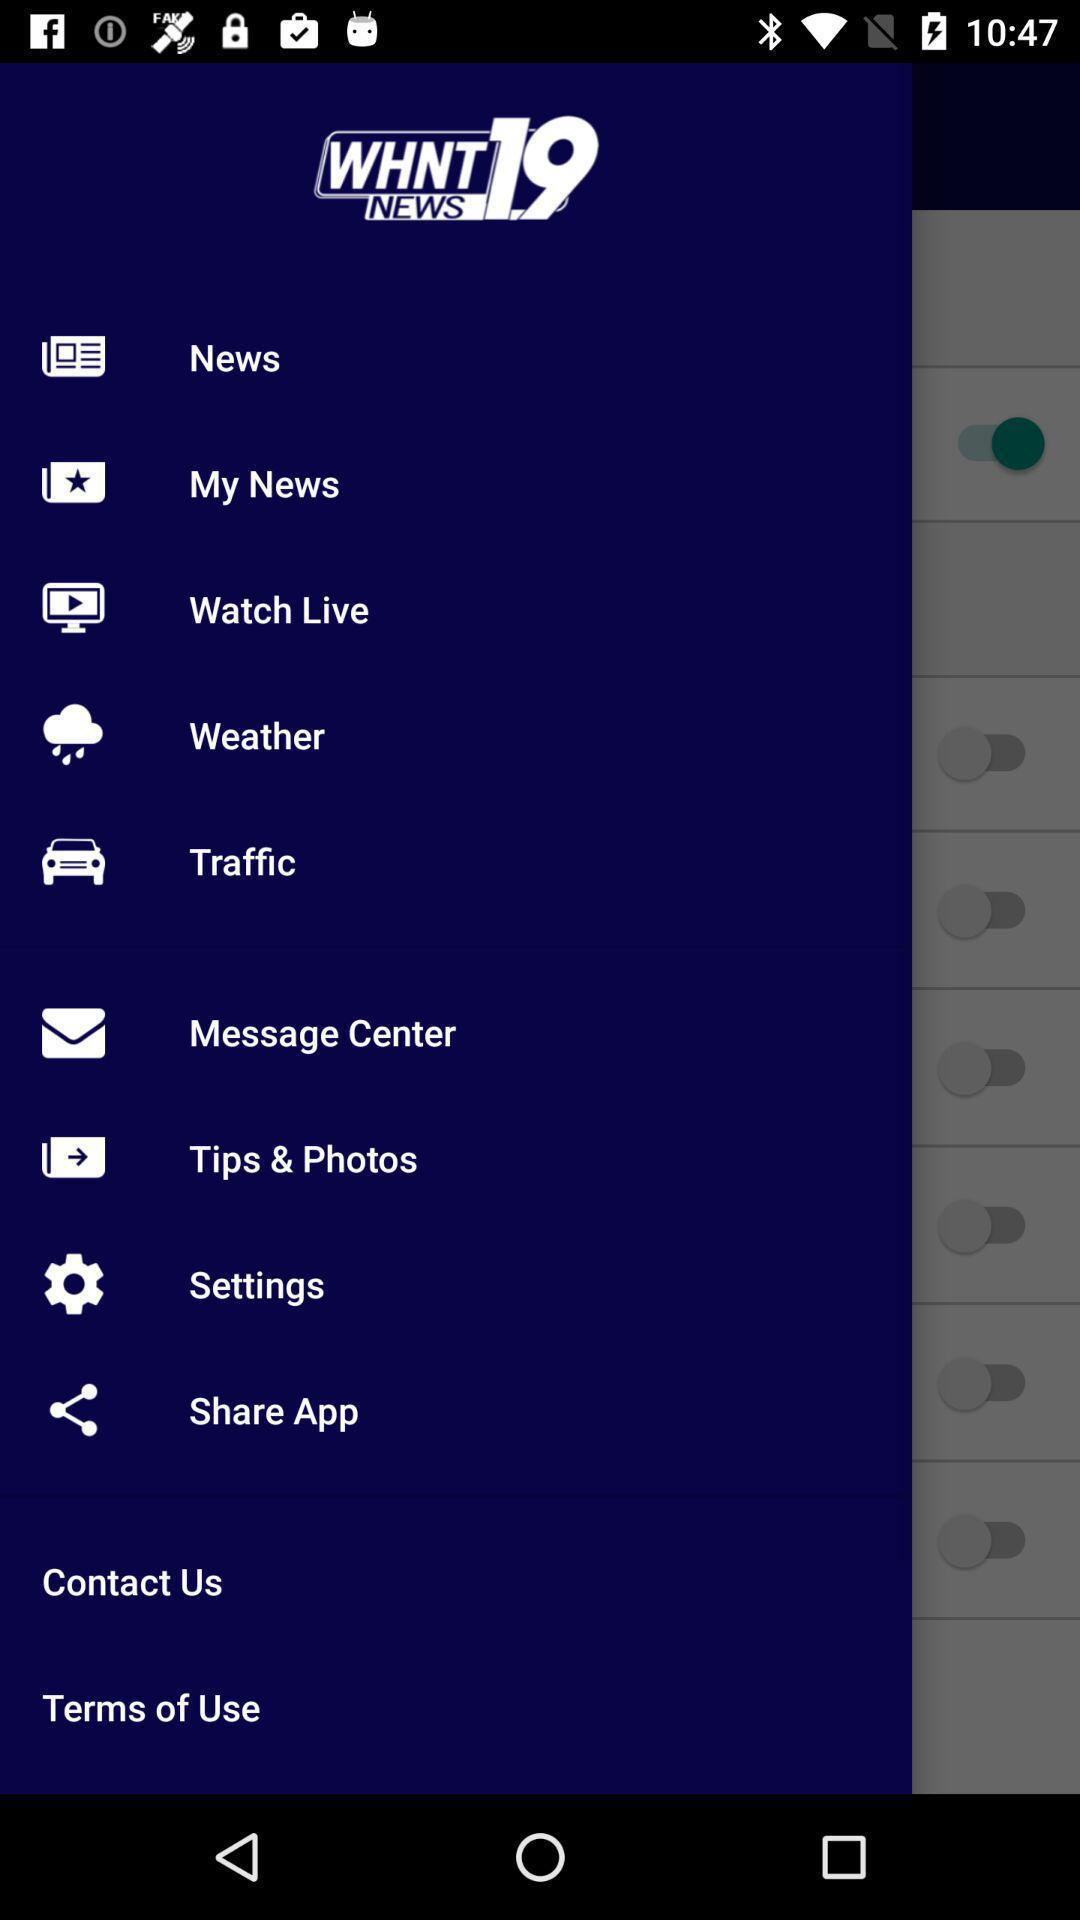What is the name of the application? The name of the application is "WHNT 19 News". 